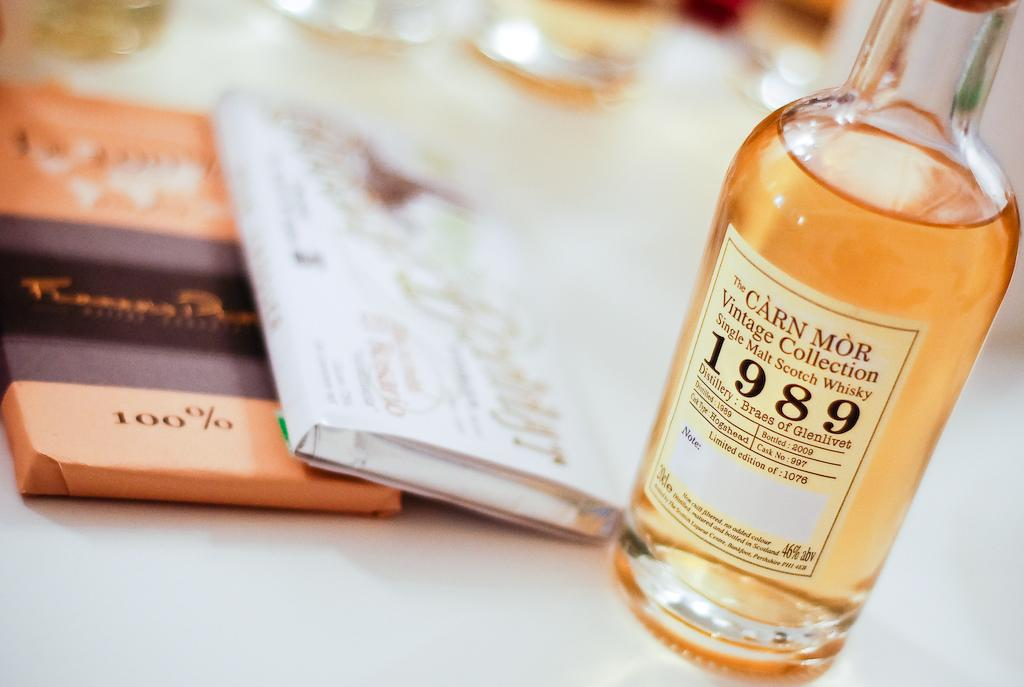<image>
Present a compact description of the photo's key features. A bottle of scotch whisky is labelled as being from 1989. 